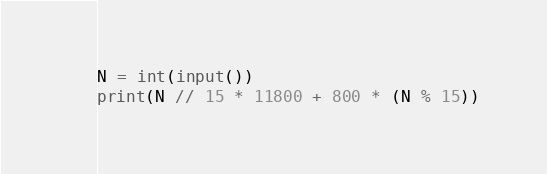Convert code to text. <code><loc_0><loc_0><loc_500><loc_500><_Python_>N = int(input())
print(N // 15 * 11800 + 800 * (N % 15))</code> 